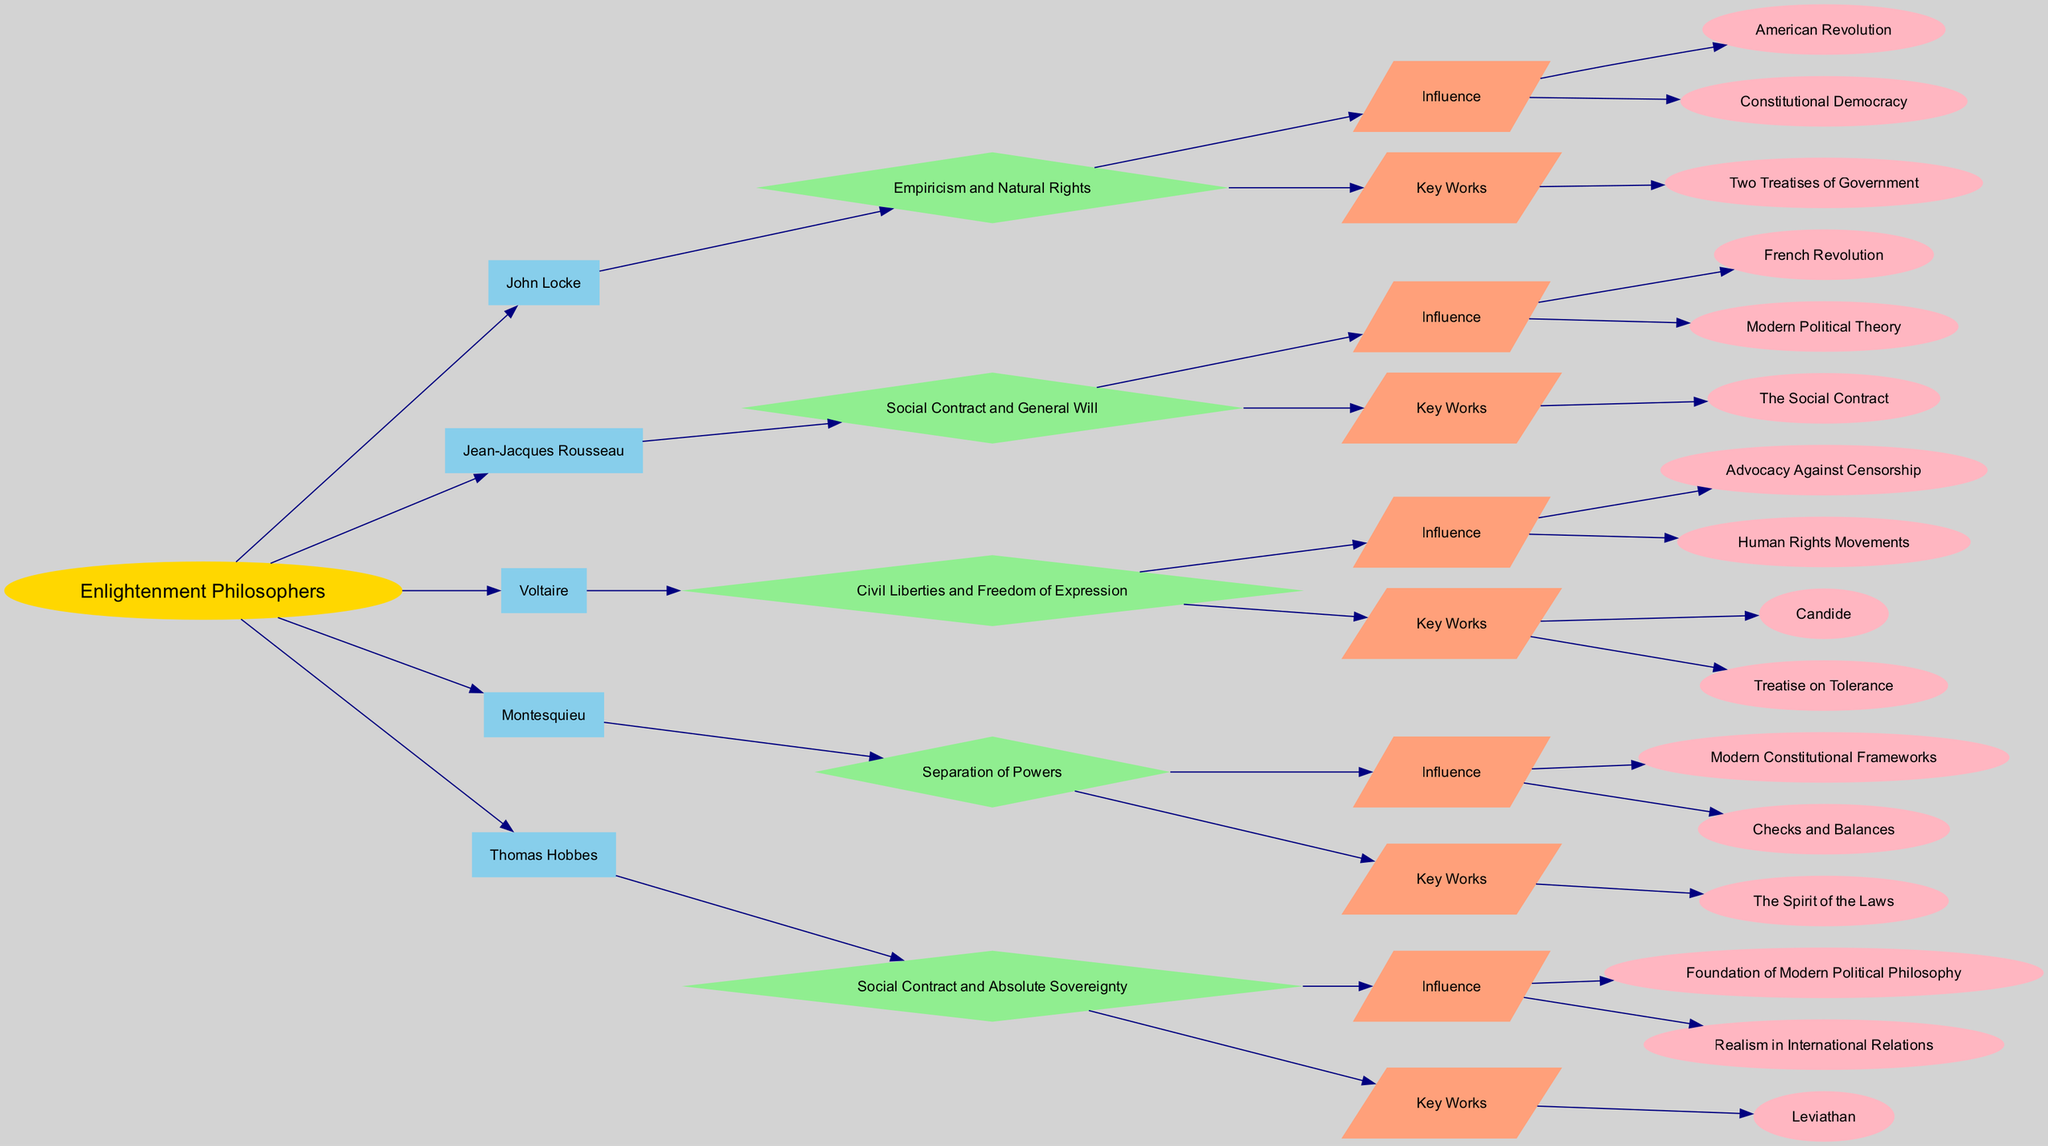What ideology is associated with John Locke? The ideology associated with John Locke is listed directly under his name in the diagram. It is clearly stated as "Empiricism and Natural Rights."
Answer: Empiricism and Natural Rights How many philosophers are represented in the diagram? To determine the number of philosophers, we count the nodes that are connected to the root node labeled "Enlightenment Philosophers." There are five such nodes: John Locke, Jean-Jacques Rousseau, Voltaire, Montesquieu, and Thomas Hobbes.
Answer: 5 Which key work is associated with Montesquieu? By following the edge from Montesquieu to the "Key Works" node and then to the specific outcomes, we find that the key work associated with Montesquieu is "The Spirit of the Laws."
Answer: The Spirit of the Laws What influence is connected to Voltaire? We look at the outcomes listed under Voltaire and identify the influences. They are "Advocacy Against Censorship" and "Human Rights Movements." The first outcome is the direct response to the question.
Answer: Advocacy Against Censorship Which philosopher emphasizes the "Social Contract and General Will"? By examining the ideologies listed for each philosopher, we identify that Jean-Jacques Rousseau emphasizes the "Social Contract and General Will." Therefore, we can directly answer who this philosopher is.
Answer: Jean-Jacques Rousseau What type of outcome is connected to Thomas Hobbes? Analyzing the outcomes under Thomas Hobbes for the "Influence" node, we find that it includes "Foundation of Modern Political Philosophy" and "Realism in International Relations." The type of outcome here can be categorized as significant political influence.
Answer: Influence Which philosopher's ideology mentions "Separation of Powers"? Upon inspecting the ideologies associated with each philosopher, we see that Montesquieu explicitly mentions "Separation of Powers." This is the exact phrase that answers the question.
Answer: Montesquieu What is one key work of John Locke? Referring to the key works listed in the outcomes for John Locke, we find that "Two Treatises of Government" is a key work mentioned there. This is the direct answer to the inquiry regarding key works.
Answer: Two Treatises of Government How many outcomes are listed for Jean-Jacques Rousseau? By looking at the "Outcomes" section under Jean-Jacques Rousseau, we identify that there are two types of outcomes mentioned: "Influence" and "Key Works." Under "Influence," there are two items, and under "Key Works," there is one. Altogether, this gives us a total of three outcomes listed.
Answer: 3 